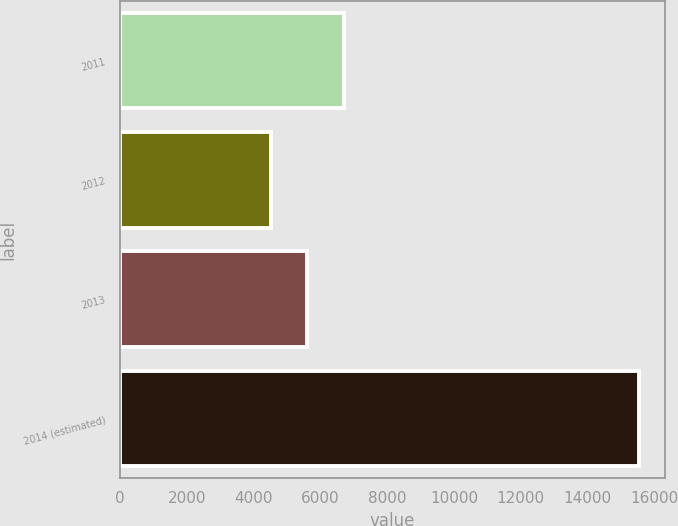Convert chart. <chart><loc_0><loc_0><loc_500><loc_500><bar_chart><fcel>2011<fcel>2012<fcel>2013<fcel>2014 (estimated)<nl><fcel>6715<fcel>4509<fcel>5612<fcel>15539<nl></chart> 